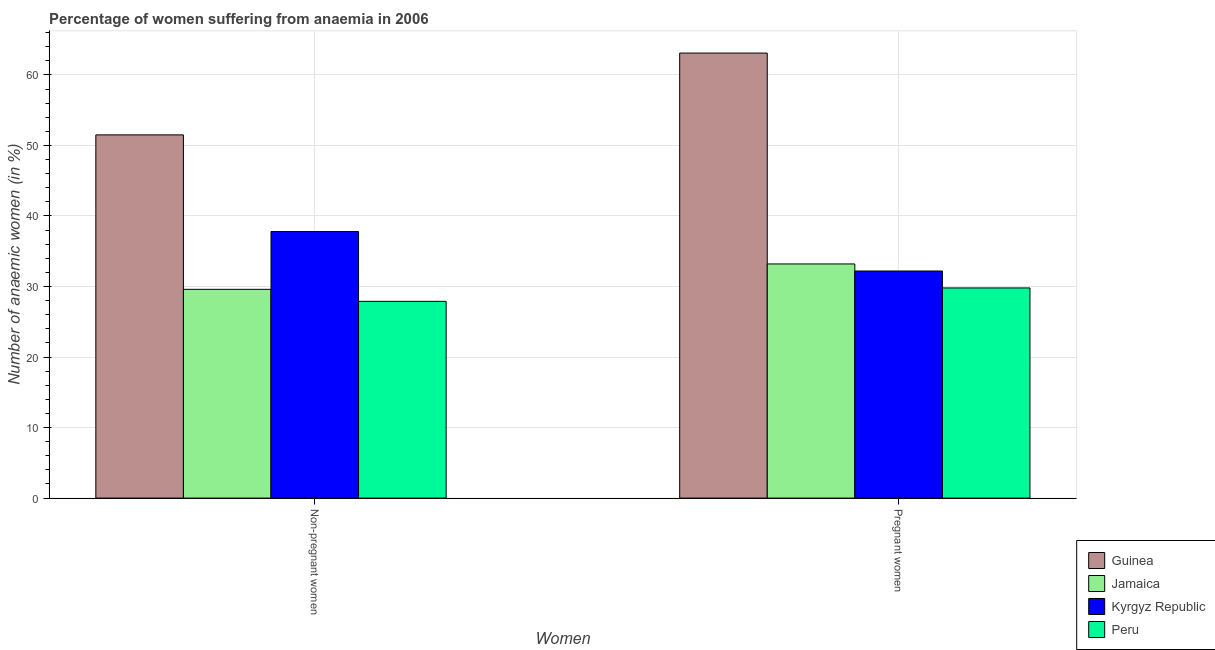Are the number of bars per tick equal to the number of legend labels?
Your answer should be compact. Yes. What is the label of the 1st group of bars from the left?
Make the answer very short. Non-pregnant women. What is the percentage of pregnant anaemic women in Jamaica?
Your answer should be compact. 33.2. Across all countries, what is the maximum percentage of pregnant anaemic women?
Provide a succinct answer. 63.1. Across all countries, what is the minimum percentage of non-pregnant anaemic women?
Your answer should be compact. 27.9. In which country was the percentage of pregnant anaemic women maximum?
Your answer should be very brief. Guinea. What is the total percentage of non-pregnant anaemic women in the graph?
Give a very brief answer. 146.8. What is the difference between the percentage of pregnant anaemic women in Kyrgyz Republic and that in Guinea?
Ensure brevity in your answer.  -30.9. What is the difference between the percentage of pregnant anaemic women in Guinea and the percentage of non-pregnant anaemic women in Peru?
Your answer should be compact. 35.2. What is the average percentage of non-pregnant anaemic women per country?
Give a very brief answer. 36.7. What is the difference between the percentage of pregnant anaemic women and percentage of non-pregnant anaemic women in Peru?
Ensure brevity in your answer.  1.9. In how many countries, is the percentage of pregnant anaemic women greater than 62 %?
Offer a very short reply. 1. What is the ratio of the percentage of pregnant anaemic women in Guinea to that in Jamaica?
Give a very brief answer. 1.9. What does the 4th bar from the left in Non-pregnant women represents?
Your response must be concise. Peru. What does the 4th bar from the right in Non-pregnant women represents?
Offer a terse response. Guinea. How many bars are there?
Give a very brief answer. 8. How many countries are there in the graph?
Give a very brief answer. 4. Are the values on the major ticks of Y-axis written in scientific E-notation?
Your response must be concise. No. Does the graph contain any zero values?
Offer a terse response. No. How many legend labels are there?
Ensure brevity in your answer.  4. How are the legend labels stacked?
Your response must be concise. Vertical. What is the title of the graph?
Your answer should be compact. Percentage of women suffering from anaemia in 2006. Does "Rwanda" appear as one of the legend labels in the graph?
Your response must be concise. No. What is the label or title of the X-axis?
Your answer should be compact. Women. What is the label or title of the Y-axis?
Your response must be concise. Number of anaemic women (in %). What is the Number of anaemic women (in %) in Guinea in Non-pregnant women?
Your answer should be very brief. 51.5. What is the Number of anaemic women (in %) in Jamaica in Non-pregnant women?
Offer a terse response. 29.6. What is the Number of anaemic women (in %) in Kyrgyz Republic in Non-pregnant women?
Your response must be concise. 37.8. What is the Number of anaemic women (in %) of Peru in Non-pregnant women?
Give a very brief answer. 27.9. What is the Number of anaemic women (in %) in Guinea in Pregnant women?
Your answer should be very brief. 63.1. What is the Number of anaemic women (in %) in Jamaica in Pregnant women?
Keep it short and to the point. 33.2. What is the Number of anaemic women (in %) of Kyrgyz Republic in Pregnant women?
Make the answer very short. 32.2. What is the Number of anaemic women (in %) of Peru in Pregnant women?
Give a very brief answer. 29.8. Across all Women, what is the maximum Number of anaemic women (in %) in Guinea?
Offer a terse response. 63.1. Across all Women, what is the maximum Number of anaemic women (in %) of Jamaica?
Offer a terse response. 33.2. Across all Women, what is the maximum Number of anaemic women (in %) of Kyrgyz Republic?
Keep it short and to the point. 37.8. Across all Women, what is the maximum Number of anaemic women (in %) in Peru?
Keep it short and to the point. 29.8. Across all Women, what is the minimum Number of anaemic women (in %) in Guinea?
Give a very brief answer. 51.5. Across all Women, what is the minimum Number of anaemic women (in %) of Jamaica?
Provide a succinct answer. 29.6. Across all Women, what is the minimum Number of anaemic women (in %) of Kyrgyz Republic?
Provide a succinct answer. 32.2. Across all Women, what is the minimum Number of anaemic women (in %) in Peru?
Provide a short and direct response. 27.9. What is the total Number of anaemic women (in %) of Guinea in the graph?
Your answer should be very brief. 114.6. What is the total Number of anaemic women (in %) in Jamaica in the graph?
Your answer should be compact. 62.8. What is the total Number of anaemic women (in %) in Kyrgyz Republic in the graph?
Your answer should be compact. 70. What is the total Number of anaemic women (in %) in Peru in the graph?
Provide a succinct answer. 57.7. What is the difference between the Number of anaemic women (in %) in Guinea in Non-pregnant women and that in Pregnant women?
Ensure brevity in your answer.  -11.6. What is the difference between the Number of anaemic women (in %) in Jamaica in Non-pregnant women and that in Pregnant women?
Give a very brief answer. -3.6. What is the difference between the Number of anaemic women (in %) in Kyrgyz Republic in Non-pregnant women and that in Pregnant women?
Offer a terse response. 5.6. What is the difference between the Number of anaemic women (in %) in Guinea in Non-pregnant women and the Number of anaemic women (in %) in Kyrgyz Republic in Pregnant women?
Provide a succinct answer. 19.3. What is the difference between the Number of anaemic women (in %) in Guinea in Non-pregnant women and the Number of anaemic women (in %) in Peru in Pregnant women?
Keep it short and to the point. 21.7. What is the difference between the Number of anaemic women (in %) in Jamaica in Non-pregnant women and the Number of anaemic women (in %) in Peru in Pregnant women?
Offer a very short reply. -0.2. What is the average Number of anaemic women (in %) of Guinea per Women?
Ensure brevity in your answer.  57.3. What is the average Number of anaemic women (in %) in Jamaica per Women?
Your answer should be compact. 31.4. What is the average Number of anaemic women (in %) of Peru per Women?
Your answer should be compact. 28.85. What is the difference between the Number of anaemic women (in %) in Guinea and Number of anaemic women (in %) in Jamaica in Non-pregnant women?
Offer a very short reply. 21.9. What is the difference between the Number of anaemic women (in %) of Guinea and Number of anaemic women (in %) of Peru in Non-pregnant women?
Ensure brevity in your answer.  23.6. What is the difference between the Number of anaemic women (in %) in Kyrgyz Republic and Number of anaemic women (in %) in Peru in Non-pregnant women?
Offer a very short reply. 9.9. What is the difference between the Number of anaemic women (in %) of Guinea and Number of anaemic women (in %) of Jamaica in Pregnant women?
Provide a short and direct response. 29.9. What is the difference between the Number of anaemic women (in %) of Guinea and Number of anaemic women (in %) of Kyrgyz Republic in Pregnant women?
Your answer should be compact. 30.9. What is the difference between the Number of anaemic women (in %) in Guinea and Number of anaemic women (in %) in Peru in Pregnant women?
Provide a short and direct response. 33.3. What is the difference between the Number of anaemic women (in %) in Jamaica and Number of anaemic women (in %) in Kyrgyz Republic in Pregnant women?
Provide a succinct answer. 1. What is the ratio of the Number of anaemic women (in %) in Guinea in Non-pregnant women to that in Pregnant women?
Make the answer very short. 0.82. What is the ratio of the Number of anaemic women (in %) in Jamaica in Non-pregnant women to that in Pregnant women?
Ensure brevity in your answer.  0.89. What is the ratio of the Number of anaemic women (in %) of Kyrgyz Republic in Non-pregnant women to that in Pregnant women?
Provide a short and direct response. 1.17. What is the ratio of the Number of anaemic women (in %) of Peru in Non-pregnant women to that in Pregnant women?
Ensure brevity in your answer.  0.94. What is the difference between the highest and the second highest Number of anaemic women (in %) of Guinea?
Your answer should be very brief. 11.6. What is the difference between the highest and the second highest Number of anaemic women (in %) of Kyrgyz Republic?
Offer a terse response. 5.6. What is the difference between the highest and the lowest Number of anaemic women (in %) in Peru?
Ensure brevity in your answer.  1.9. 